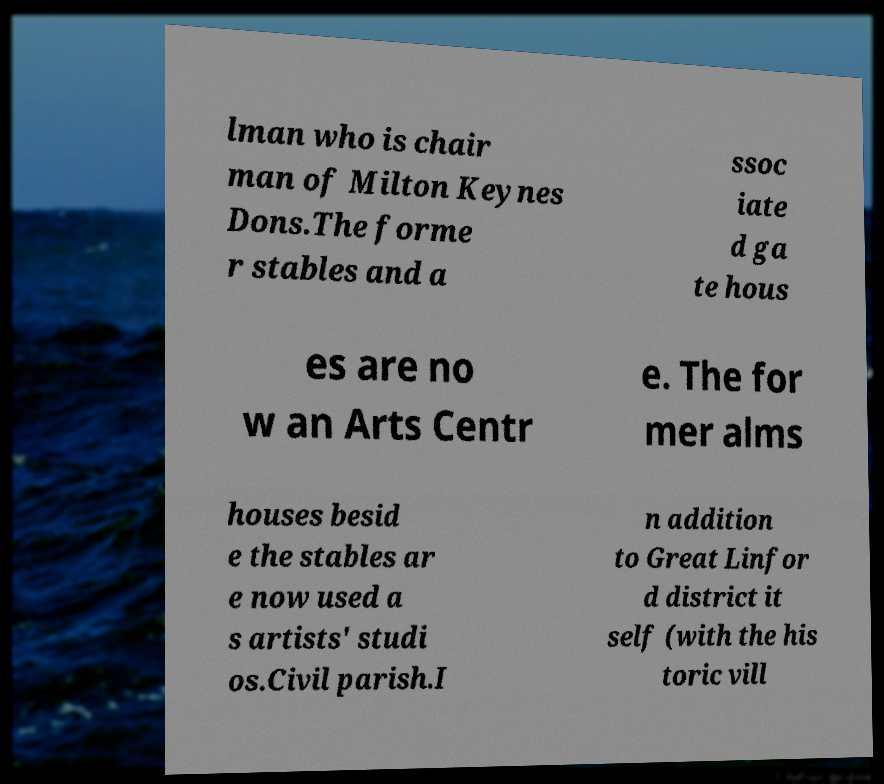Please read and relay the text visible in this image. What does it say? lman who is chair man of Milton Keynes Dons.The forme r stables and a ssoc iate d ga te hous es are no w an Arts Centr e. The for mer alms houses besid e the stables ar e now used a s artists' studi os.Civil parish.I n addition to Great Linfor d district it self (with the his toric vill 